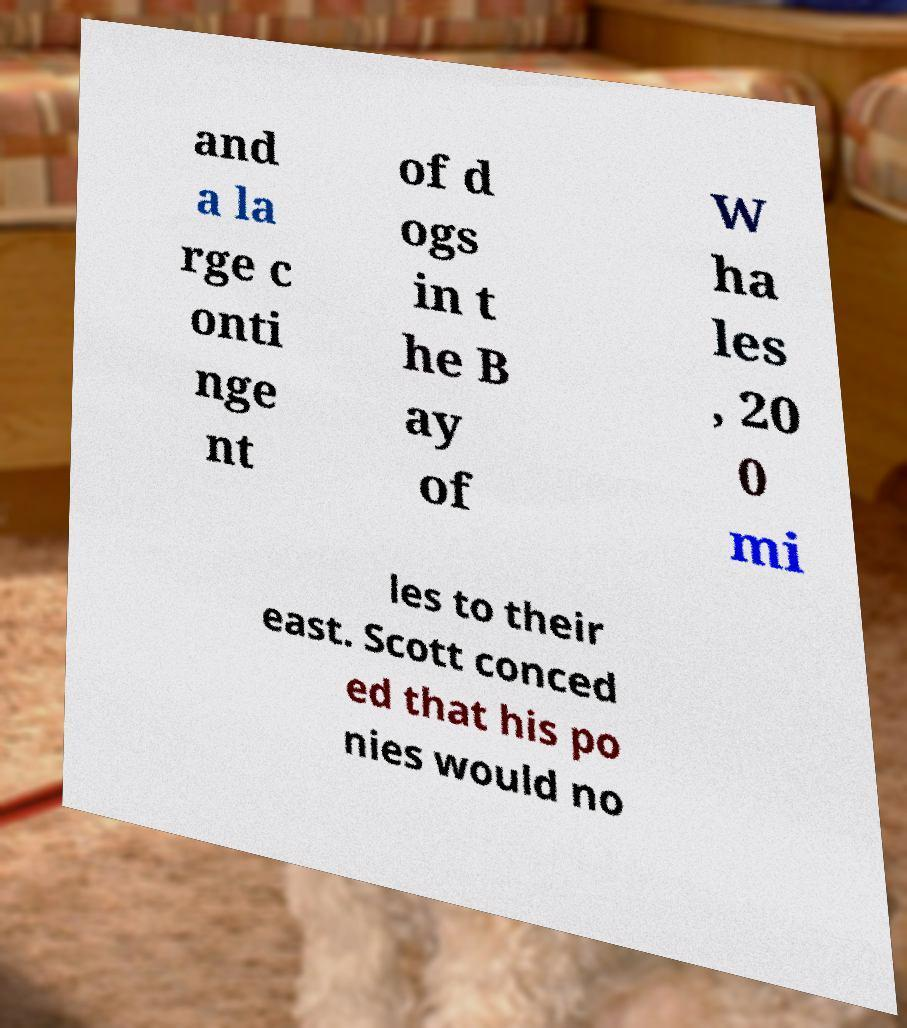What messages or text are displayed in this image? I need them in a readable, typed format. and a la rge c onti nge nt of d ogs in t he B ay of W ha les , 20 0 mi les to their east. Scott conced ed that his po nies would no 